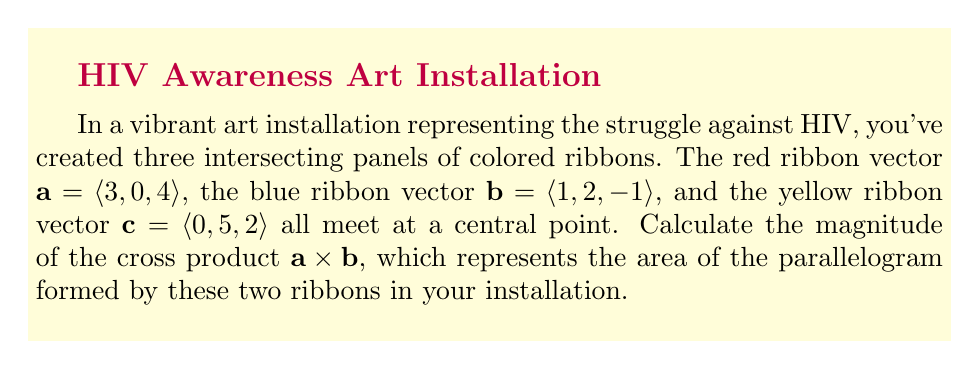Teach me how to tackle this problem. Let's approach this step-by-step:

1) The cross product of two vectors $\mathbf{a} = \langle a_1, a_2, a_3 \rangle$ and $\mathbf{b} = \langle b_1, b_2, b_3 \rangle$ is given by:

   $$\mathbf{a} \times \mathbf{b} = \langle a_2b_3 - a_3b_2, a_3b_1 - a_1b_3, a_1b_2 - a_2b_1 \rangle$$

2) In this case, $\mathbf{a} = \langle 3, 0, 4 \rangle$ and $\mathbf{b} = \langle 1, 2, -1 \rangle$

3) Let's calculate each component:
   
   $i: (0)(-1) - (4)(2) = -8$
   $j: (4)(1) - (3)(-1) = 7$
   $k: (3)(2) - (0)(1) = 6$

4) Therefore, $\mathbf{a} \times \mathbf{b} = \langle -8, 7, 6 \rangle$

5) The magnitude of this cross product vector is given by:

   $$|\mathbf{a} \times \mathbf{b}| = \sqrt{(-8)^2 + 7^2 + 6^2}$$

6) Simplifying:
   
   $$|\mathbf{a} \times \mathbf{b}| = \sqrt{64 + 49 + 36} = \sqrt{149}$$

The magnitude of the cross product represents the area of the parallelogram formed by vectors $\mathbf{a}$ and $\mathbf{b}$ in your art installation.
Answer: $\sqrt{149}$ square units 